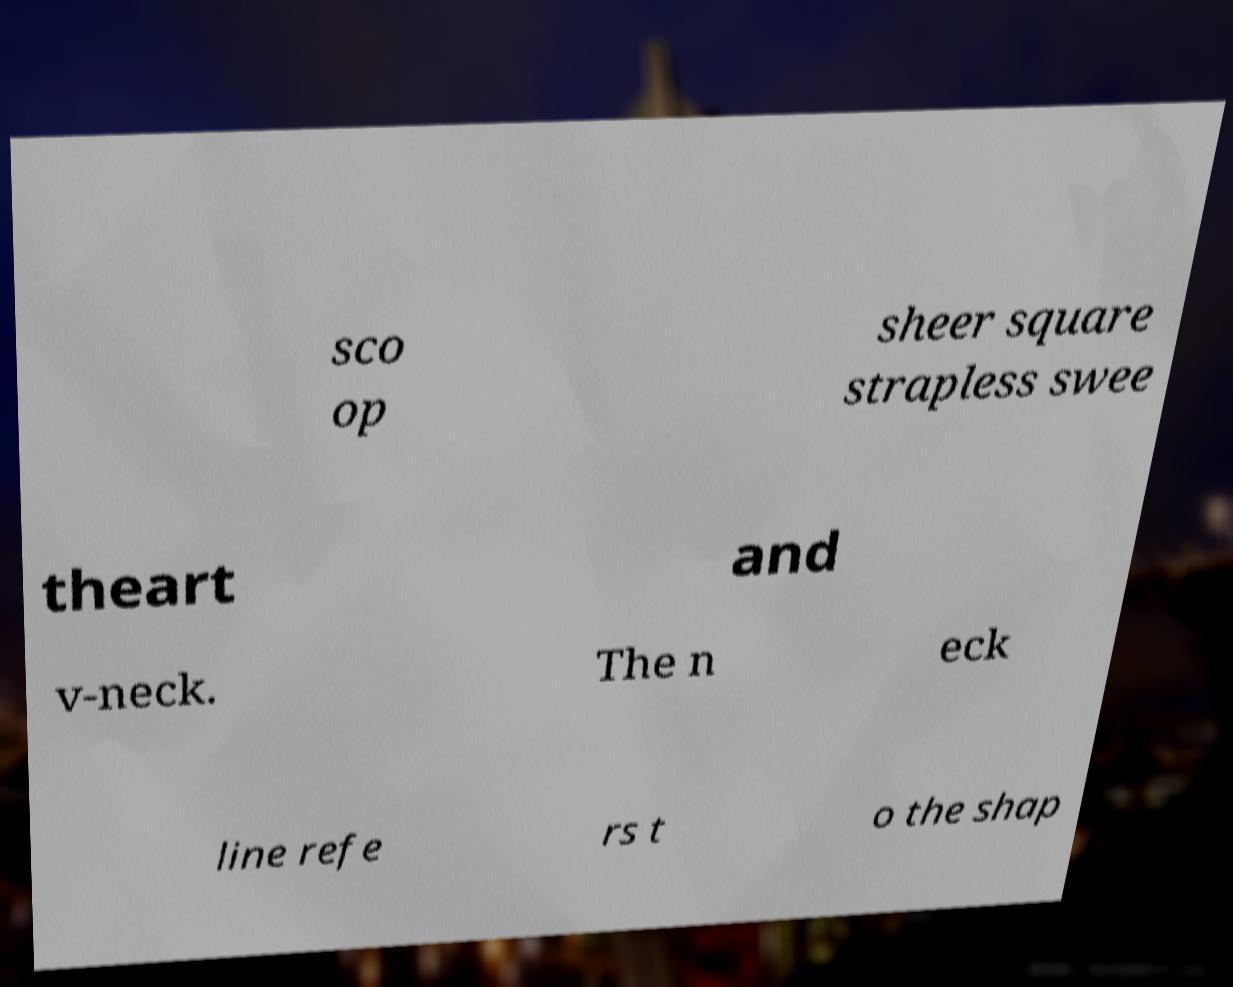What messages or text are displayed in this image? I need them in a readable, typed format. sco op sheer square strapless swee theart and v-neck. The n eck line refe rs t o the shap 